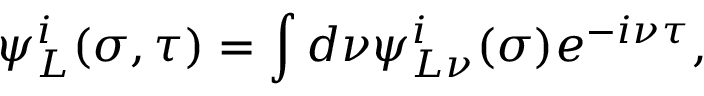Convert formula to latex. <formula><loc_0><loc_0><loc_500><loc_500>\psi _ { L } ^ { i } ( \sigma , \tau ) = \int d \nu \psi _ { L \nu } ^ { i } ( \sigma ) e ^ { - i \nu \tau } ,</formula> 